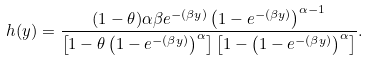<formula> <loc_0><loc_0><loc_500><loc_500>h ( y ) = \frac { ( 1 - \theta ) \alpha \beta e ^ { - ( \beta y ) } \left ( 1 - e ^ { - ( \beta y ) } \right ) ^ { \alpha - 1 } } { \left [ 1 - \theta \left ( 1 - e ^ { - ( \beta y ) } \right ) ^ { \alpha } \right ] \left [ 1 - \left ( 1 - e ^ { - ( \beta y ) } \right ) ^ { \alpha } \right ] } .</formula> 